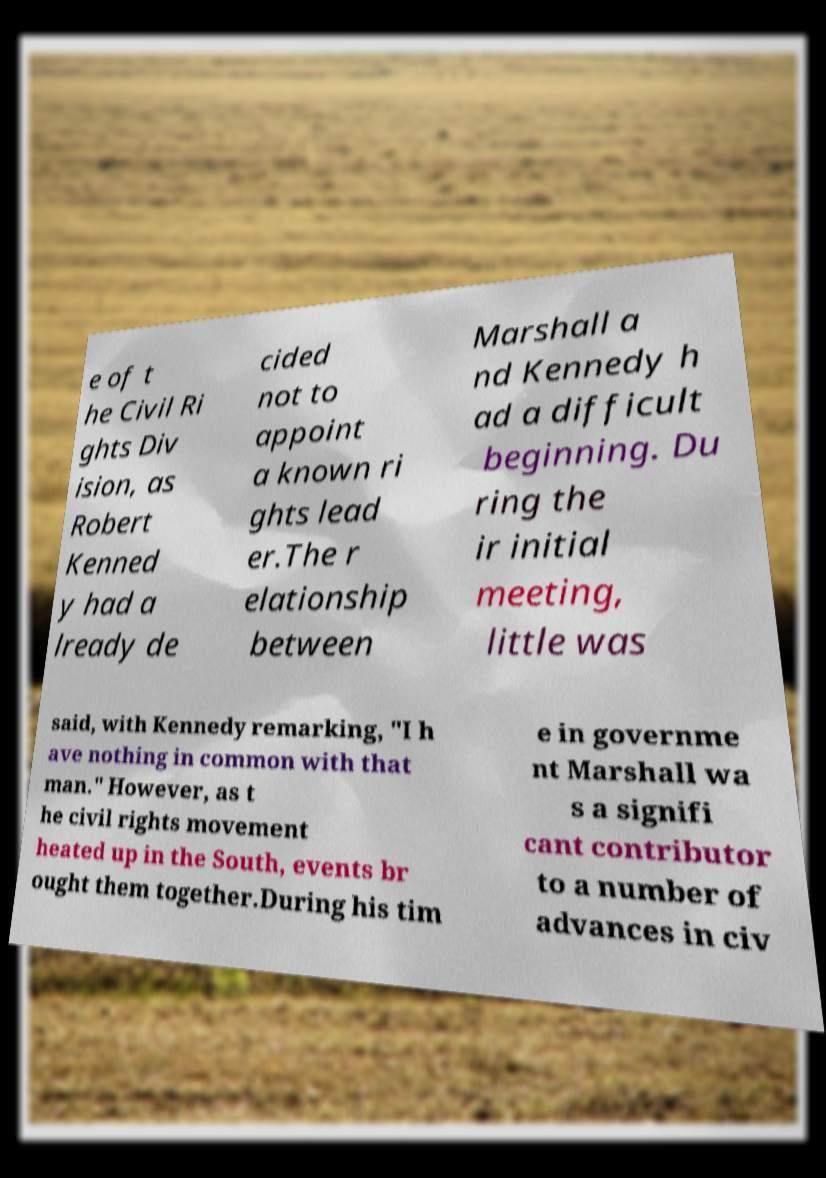I need the written content from this picture converted into text. Can you do that? e of t he Civil Ri ghts Div ision, as Robert Kenned y had a lready de cided not to appoint a known ri ghts lead er.The r elationship between Marshall a nd Kennedy h ad a difficult beginning. Du ring the ir initial meeting, little was said, with Kennedy remarking, "I h ave nothing in common with that man." However, as t he civil rights movement heated up in the South, events br ought them together.During his tim e in governme nt Marshall wa s a signifi cant contributor to a number of advances in civ 